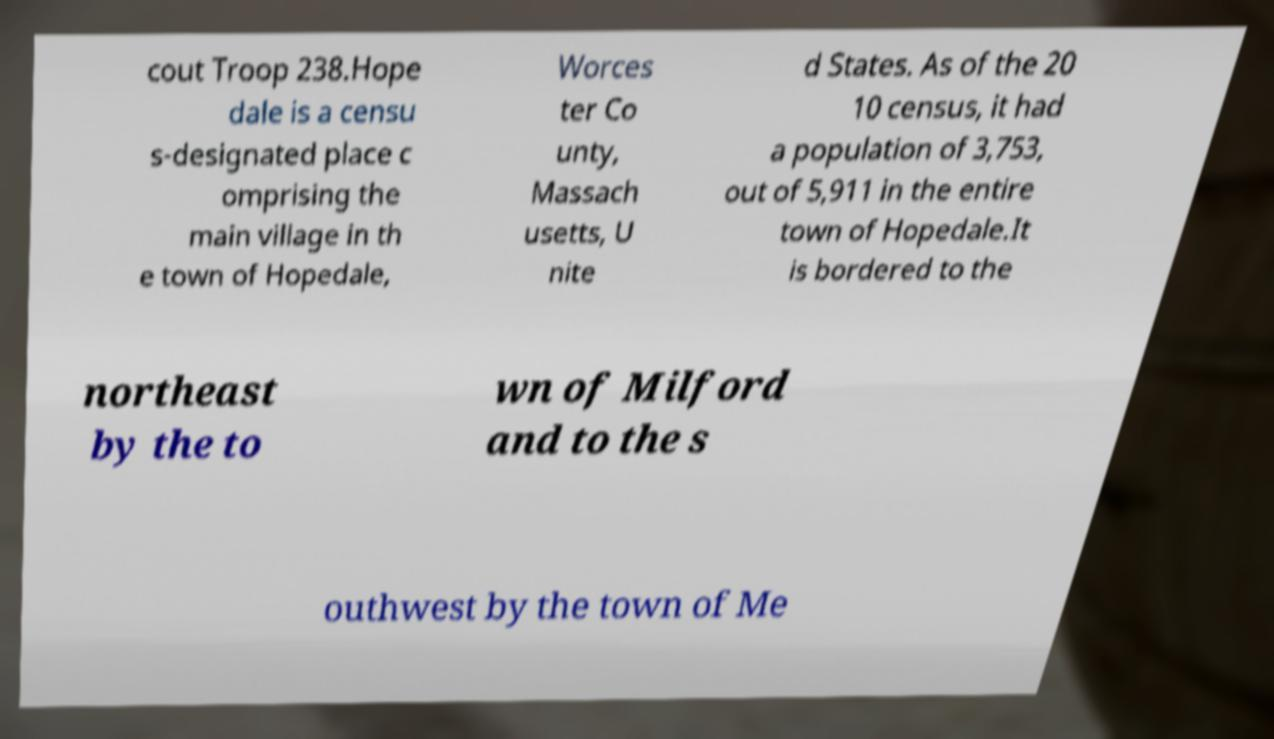Can you read and provide the text displayed in the image?This photo seems to have some interesting text. Can you extract and type it out for me? cout Troop 238.Hope dale is a censu s-designated place c omprising the main village in th e town of Hopedale, Worces ter Co unty, Massach usetts, U nite d States. As of the 20 10 census, it had a population of 3,753, out of 5,911 in the entire town of Hopedale.It is bordered to the northeast by the to wn of Milford and to the s outhwest by the town of Me 